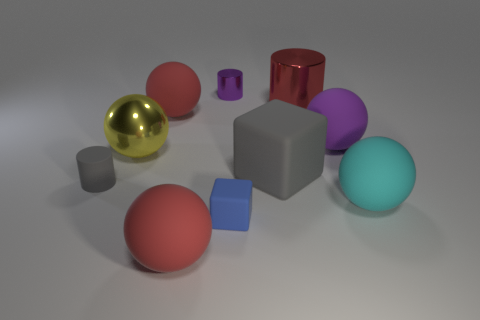Subtract 3 spheres. How many spheres are left? 2 Subtract all yellow spheres. How many spheres are left? 4 Subtract all shiny cylinders. How many cylinders are left? 1 Subtract all brown spheres. Subtract all red blocks. How many spheres are left? 5 Subtract all cubes. How many objects are left? 8 Subtract 1 purple cylinders. How many objects are left? 9 Subtract all small purple cylinders. Subtract all large purple things. How many objects are left? 8 Add 4 gray matte cylinders. How many gray matte cylinders are left? 5 Add 8 big yellow matte cylinders. How many big yellow matte cylinders exist? 8 